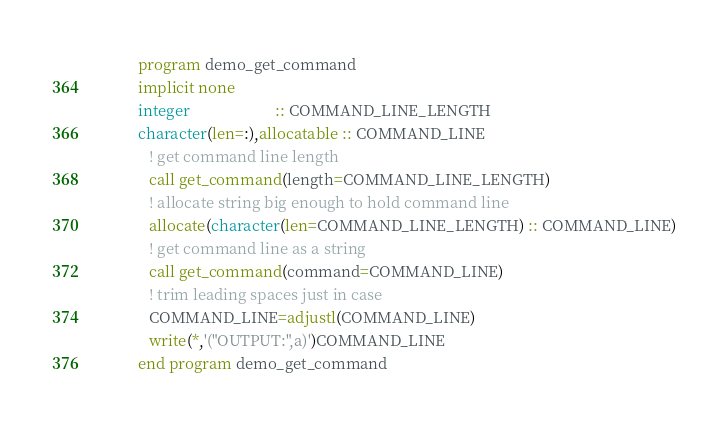<code> <loc_0><loc_0><loc_500><loc_500><_FORTRAN_>          program demo_get_command
          implicit none
          integer                      :: COMMAND_LINE_LENGTH
          character(len=:),allocatable :: COMMAND_LINE
             ! get command line length
             call get_command(length=COMMAND_LINE_LENGTH)
             ! allocate string big enough to hold command line
             allocate(character(len=COMMAND_LINE_LENGTH) :: COMMAND_LINE)
             ! get command line as a string
             call get_command(command=COMMAND_LINE)
             ! trim leading spaces just in case
             COMMAND_LINE=adjustl(COMMAND_LINE)
             write(*,'("OUTPUT:",a)')COMMAND_LINE
          end program demo_get_command
</code> 